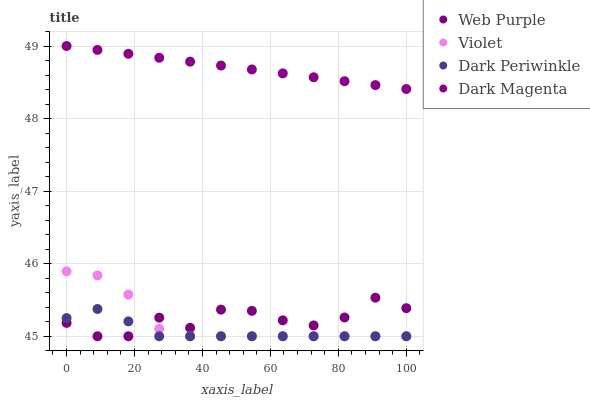Does Dark Periwinkle have the minimum area under the curve?
Answer yes or no. Yes. Does Dark Magenta have the maximum area under the curve?
Answer yes or no. Yes. Does Dark Magenta have the minimum area under the curve?
Answer yes or no. No. Does Dark Periwinkle have the maximum area under the curve?
Answer yes or no. No. Is Dark Magenta the smoothest?
Answer yes or no. Yes. Is Web Purple the roughest?
Answer yes or no. Yes. Is Dark Periwinkle the smoothest?
Answer yes or no. No. Is Dark Periwinkle the roughest?
Answer yes or no. No. Does Web Purple have the lowest value?
Answer yes or no. Yes. Does Dark Magenta have the lowest value?
Answer yes or no. No. Does Dark Magenta have the highest value?
Answer yes or no. Yes. Does Dark Periwinkle have the highest value?
Answer yes or no. No. Is Violet less than Dark Magenta?
Answer yes or no. Yes. Is Dark Magenta greater than Dark Periwinkle?
Answer yes or no. Yes. Does Violet intersect Web Purple?
Answer yes or no. Yes. Is Violet less than Web Purple?
Answer yes or no. No. Is Violet greater than Web Purple?
Answer yes or no. No. Does Violet intersect Dark Magenta?
Answer yes or no. No. 